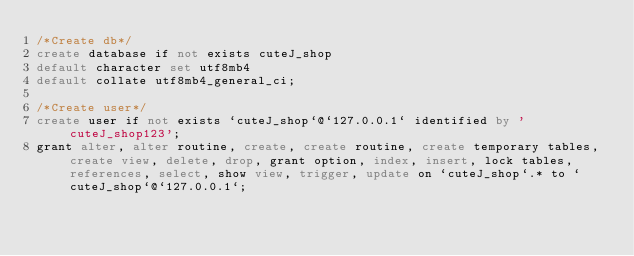Convert code to text. <code><loc_0><loc_0><loc_500><loc_500><_SQL_>/*Create db*/
create database if not exists cuteJ_shop
default character set utf8mb4
default collate utf8mb4_general_ci;

/*Create user*/
create user if not exists `cuteJ_shop`@`127.0.0.1` identified by 'cuteJ_shop123';
grant alter, alter routine, create, create routine, create temporary tables, create view, delete, drop, grant option, index, insert, lock tables, references, select, show view, trigger, update on `cuteJ_shop`.* to `cuteJ_shop`@`127.0.0.1`;
</code> 